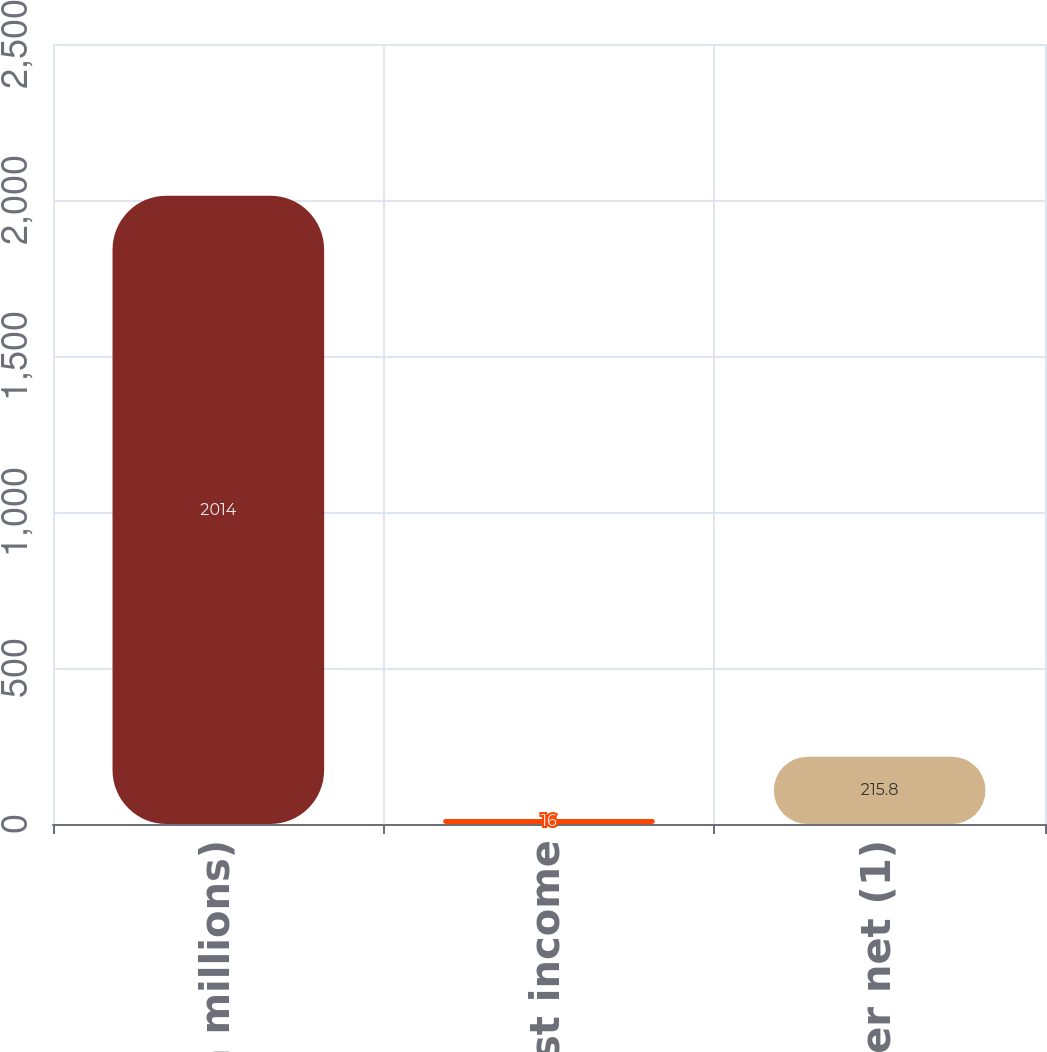Convert chart. <chart><loc_0><loc_0><loc_500><loc_500><bar_chart><fcel>(In millions)<fcel>Interest income<fcel>Other net (1)<nl><fcel>2014<fcel>16<fcel>215.8<nl></chart> 